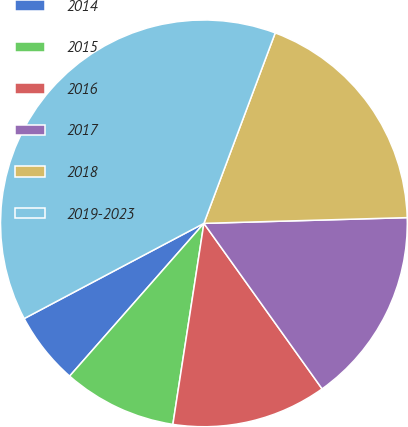Convert chart to OTSL. <chart><loc_0><loc_0><loc_500><loc_500><pie_chart><fcel>2014<fcel>2015<fcel>2016<fcel>2017<fcel>2018<fcel>2019-2023<nl><fcel>5.77%<fcel>9.04%<fcel>12.31%<fcel>15.58%<fcel>18.85%<fcel>38.46%<nl></chart> 